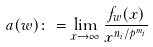<formula> <loc_0><loc_0><loc_500><loc_500>a ( w ) \colon = \lim _ { x \to \infty } \frac { f _ { w } ( x ) } { x ^ { n _ { i } / p ^ { m _ { i } } } }</formula> 